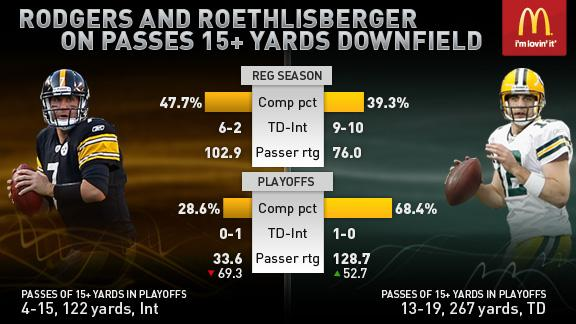Indicate a few pertinent items in this graphic. The color of the rugby ball is brown, not white. The helmet color of the player in the white jersey is yellow. 